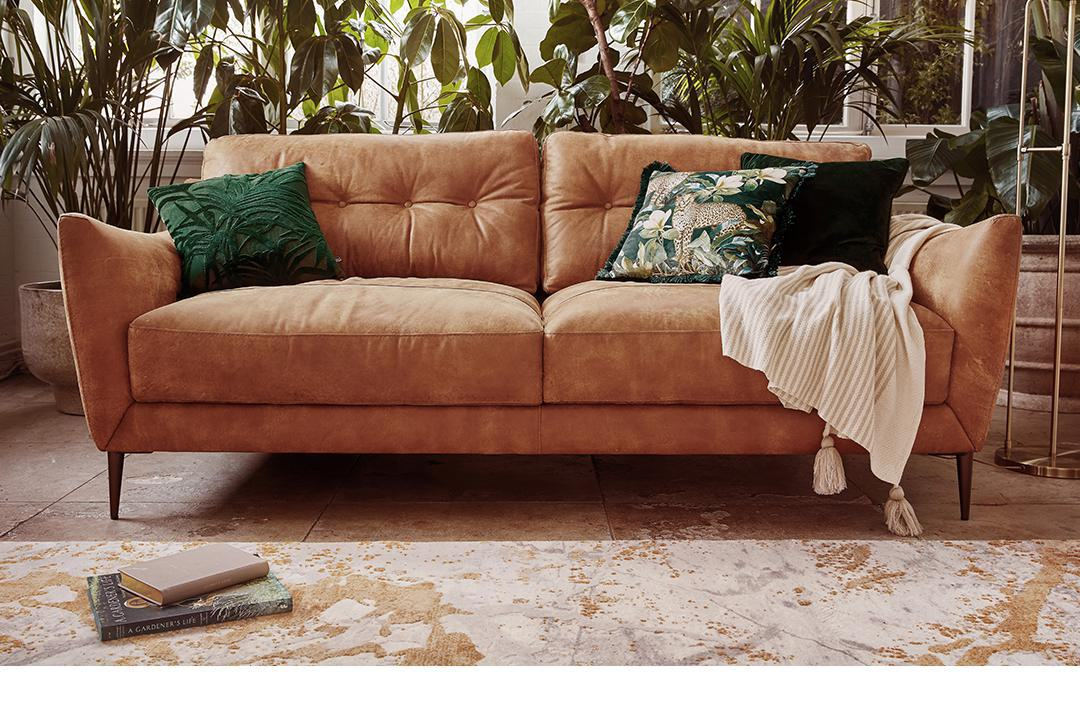Is there a sofa in the image? Yes, there is a plush, three-seat sofa in a velvety tan color, adorned with an assortment of decorative pillows and a cozy white throw draped over one side. 